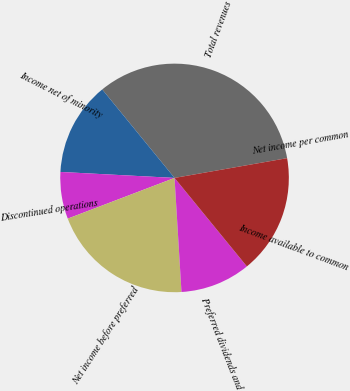Convert chart to OTSL. <chart><loc_0><loc_0><loc_500><loc_500><pie_chart><fcel>Total revenues<fcel>Income net of minority<fcel>Discontinued operations<fcel>Net income before preferred<fcel>Preferred dividends and<fcel>Income available to common<fcel>Net income per common<nl><fcel>33.14%<fcel>13.26%<fcel>6.63%<fcel>20.17%<fcel>9.94%<fcel>16.86%<fcel>0.0%<nl></chart> 